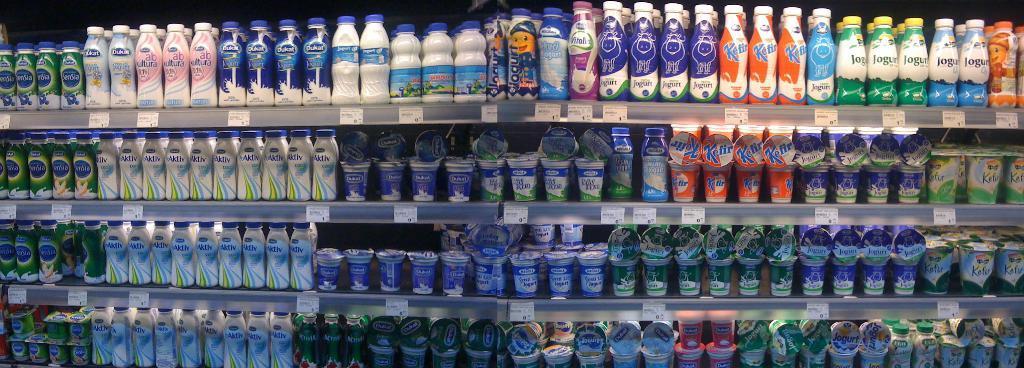In one or two sentences, can you explain what this image depicts? There is a rack. There are so many bottles. The bottle and cup has a stickers. On the left side we have a bottles. On the bottom side we have cups. 